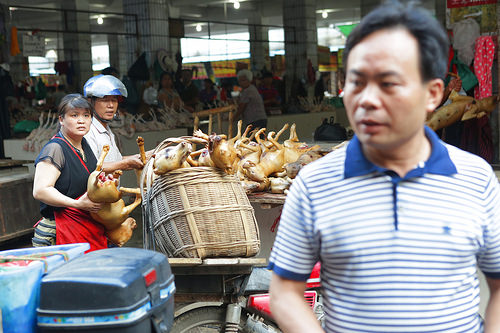<image>
Can you confirm if the helmet is above the apron? No. The helmet is not positioned above the apron. The vertical arrangement shows a different relationship. 